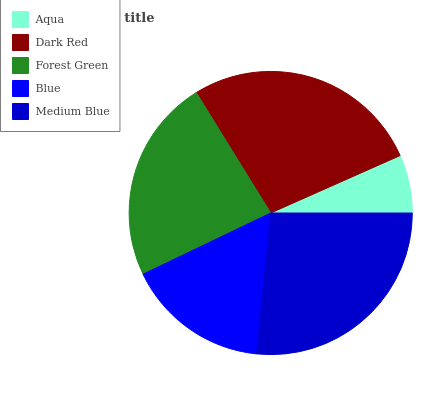Is Aqua the minimum?
Answer yes or no. Yes. Is Dark Red the maximum?
Answer yes or no. Yes. Is Forest Green the minimum?
Answer yes or no. No. Is Forest Green the maximum?
Answer yes or no. No. Is Dark Red greater than Forest Green?
Answer yes or no. Yes. Is Forest Green less than Dark Red?
Answer yes or no. Yes. Is Forest Green greater than Dark Red?
Answer yes or no. No. Is Dark Red less than Forest Green?
Answer yes or no. No. Is Forest Green the high median?
Answer yes or no. Yes. Is Forest Green the low median?
Answer yes or no. Yes. Is Medium Blue the high median?
Answer yes or no. No. Is Medium Blue the low median?
Answer yes or no. No. 